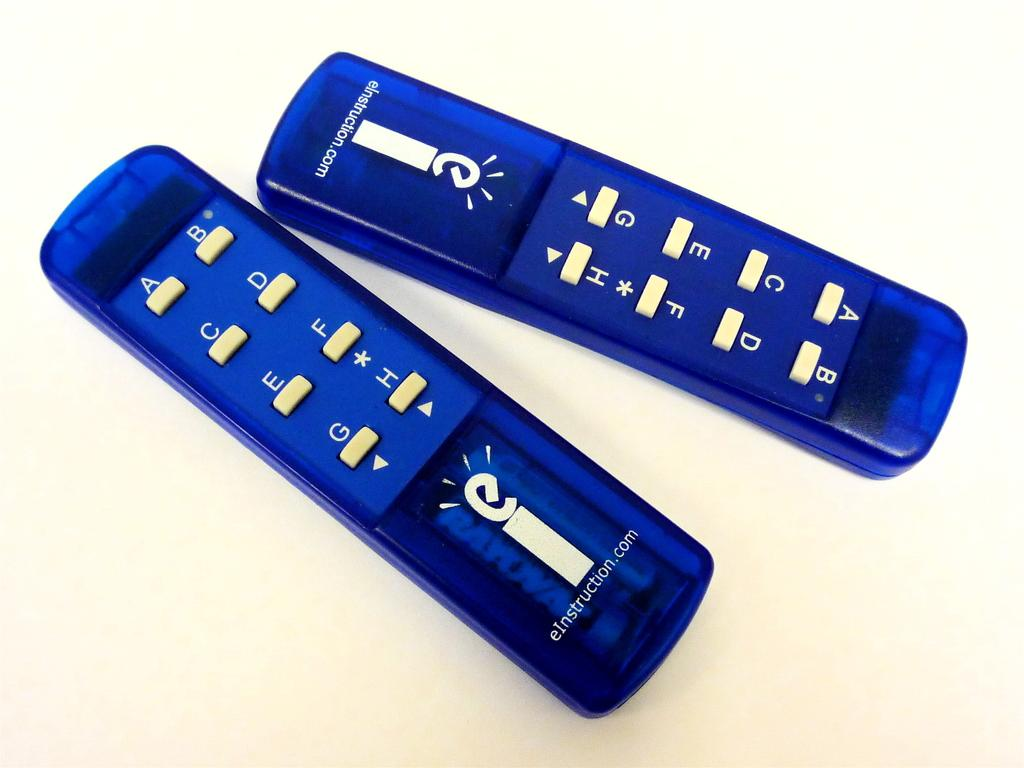<image>
Create a compact narrative representing the image presented. Two remotes have the website eInstruction.com on them. 